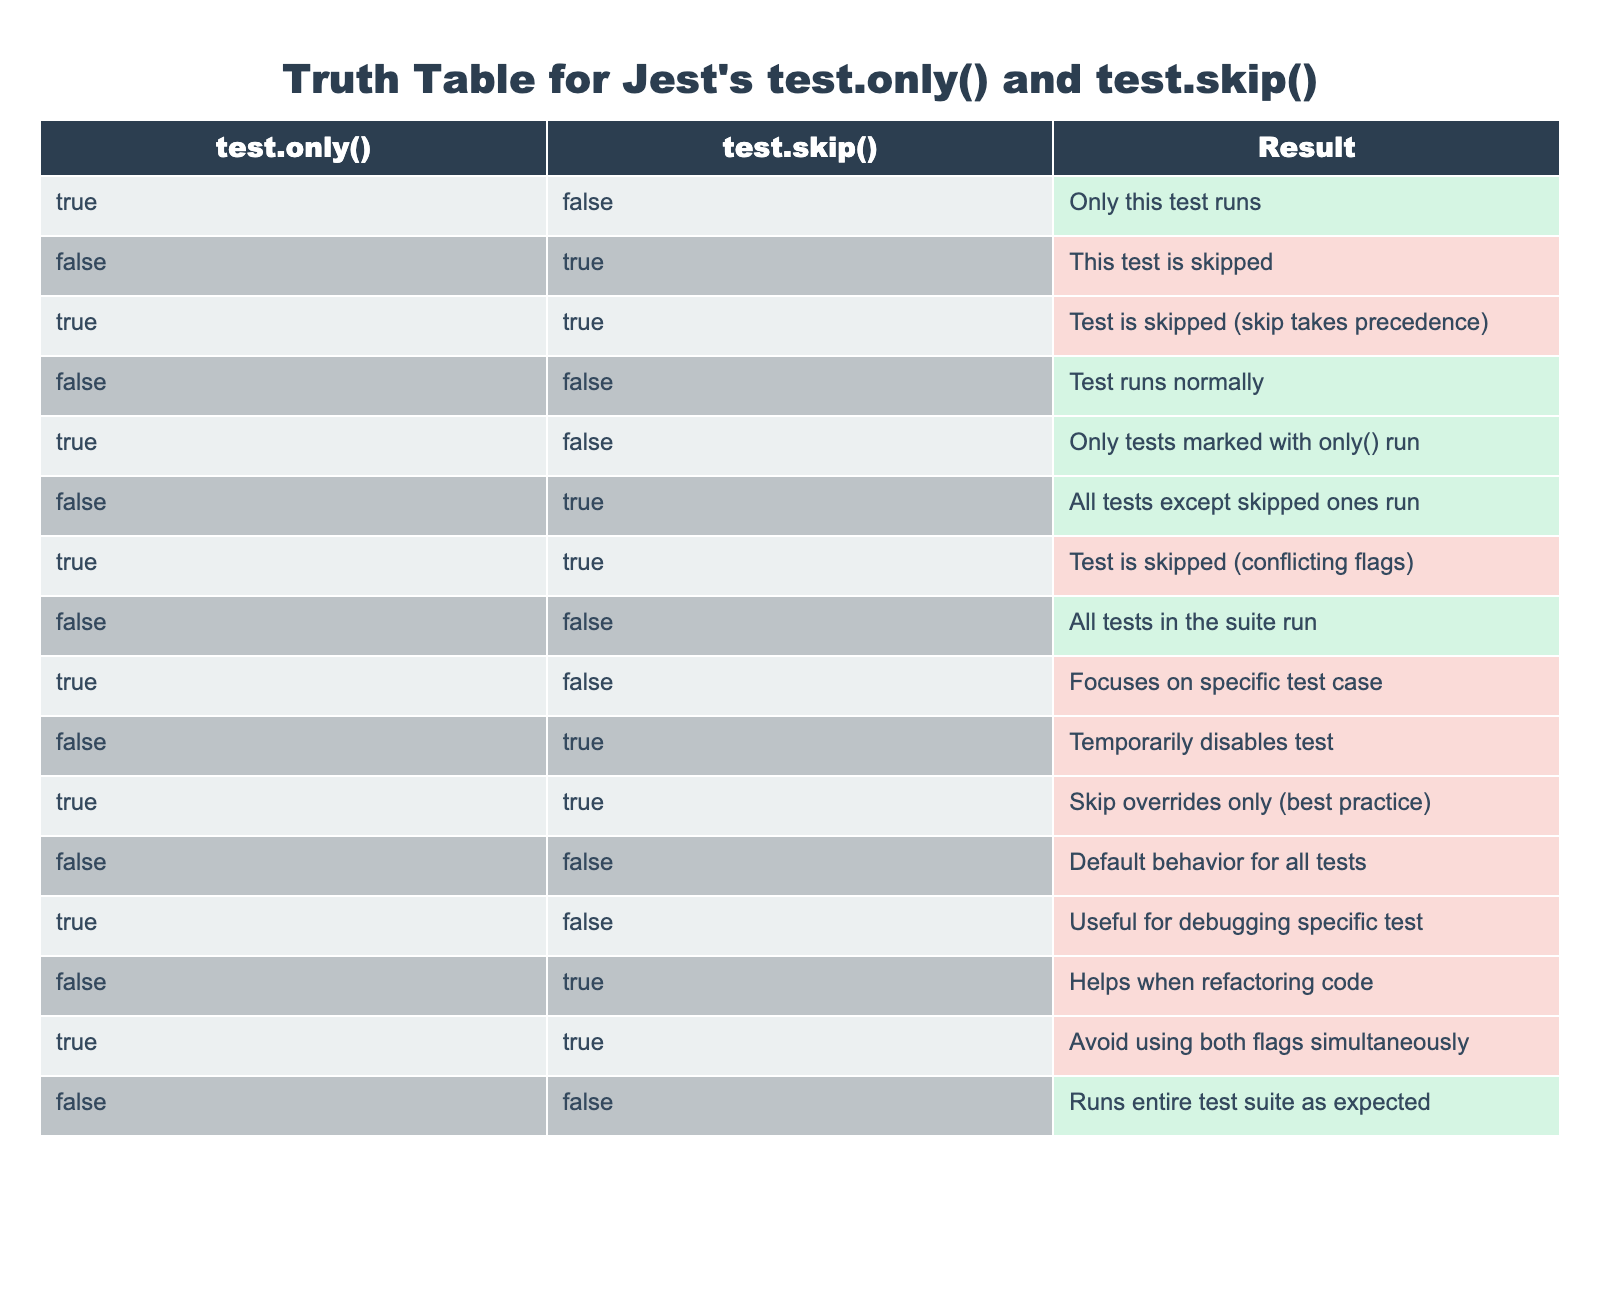What does "test.skip()" do? According to the table, when "test.skip()" is applied and "test.only()" is not present, any test marked with "test.skip()" will not run. This is shown in the entry where "false" is for "test.only()" and "true" is for "test.skip()", resulting in "This test is skipped".
Answer: This test is skipped How do "test.only()" and "test.skip()" interact when both are used? The table indicates that having both functions defined will lead to the scenario where "test.skip()" takes precedence. This is evident in the row where "true" for "test.only()" and "true" for "test.skip()" results in "Test is skipped (skip takes precedence)".
Answer: Test is skipped What will happen if neither function is used? The table specifies that when both "test.only()" and "test.skip()" are set to false, the result is that all tests in the suite run normally. This is detailed in the entry where both values are false, leading to "Test runs normally".
Answer: Test runs normally Can you run tests that are skipped? The result of using "test.skip()" clearly states that tests marked to be skipped will not run, as indicated by the entry where "false" for "test.only()" and "true" for "test.skip()" notes "All tests except skipped ones run". Therefore, skipped tests do not run.
Answer: No What does the combination of both flags indicate about best practices? The table outlines that using both "test.only()" and "test.skip()" at the same time is discouraged. Specifically, it mentions that the best practice is to avoid using both simultaneously, leading to potential conflicts. This is highlighted in the entry where both flags are true, resulting in "Skip overrides only (best practice)".
Answer: Avoid using both flags simultaneously 